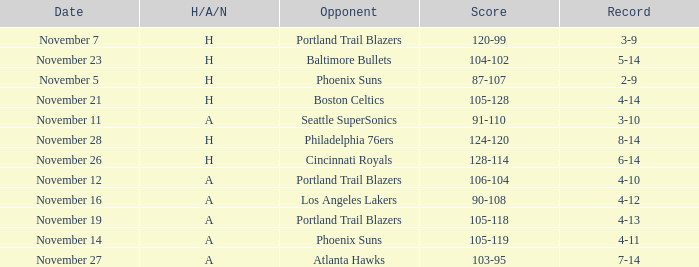On what Date was the Score 105-128? November 21. 